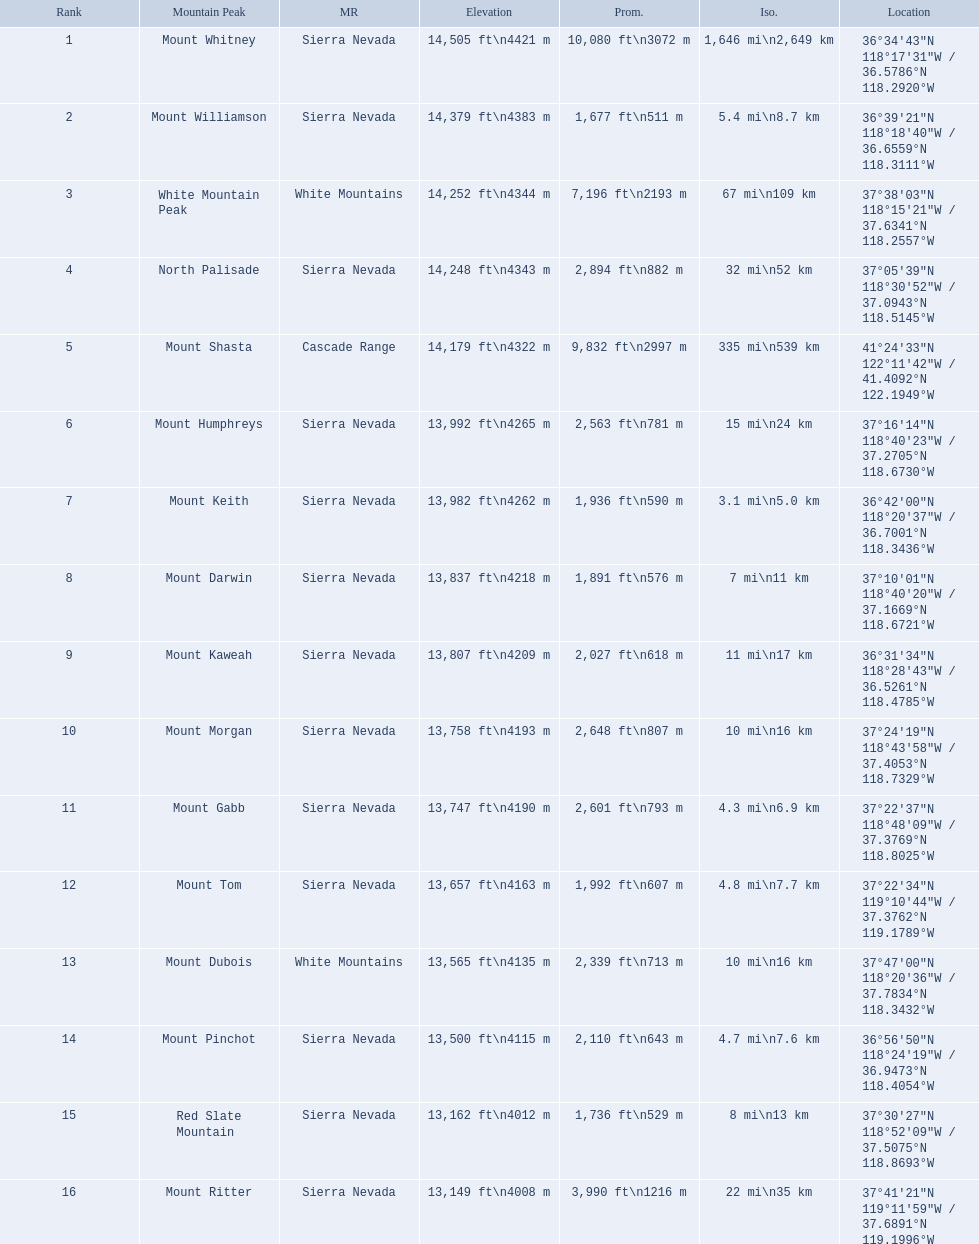Which mountain peaks are lower than 14,000 ft? Mount Humphreys, Mount Keith, Mount Darwin, Mount Kaweah, Mount Morgan, Mount Gabb, Mount Tom, Mount Dubois, Mount Pinchot, Red Slate Mountain, Mount Ritter. Are any of them below 13,500? if so, which ones? Red Slate Mountain, Mount Ritter. What's the lowest peak? 13,149 ft\n4008 m. Write the full table. {'header': ['Rank', 'Mountain Peak', 'MR', 'Elevation', 'Prom.', 'Iso.', 'Location'], 'rows': [['1', 'Mount Whitney', 'Sierra Nevada', '14,505\xa0ft\\n4421\xa0m', '10,080\xa0ft\\n3072\xa0m', '1,646\xa0mi\\n2,649\xa0km', '36°34′43″N 118°17′31″W\ufeff / \ufeff36.5786°N 118.2920°W'], ['2', 'Mount Williamson', 'Sierra Nevada', '14,379\xa0ft\\n4383\xa0m', '1,677\xa0ft\\n511\xa0m', '5.4\xa0mi\\n8.7\xa0km', '36°39′21″N 118°18′40″W\ufeff / \ufeff36.6559°N 118.3111°W'], ['3', 'White Mountain Peak', 'White Mountains', '14,252\xa0ft\\n4344\xa0m', '7,196\xa0ft\\n2193\xa0m', '67\xa0mi\\n109\xa0km', '37°38′03″N 118°15′21″W\ufeff / \ufeff37.6341°N 118.2557°W'], ['4', 'North Palisade', 'Sierra Nevada', '14,248\xa0ft\\n4343\xa0m', '2,894\xa0ft\\n882\xa0m', '32\xa0mi\\n52\xa0km', '37°05′39″N 118°30′52″W\ufeff / \ufeff37.0943°N 118.5145°W'], ['5', 'Mount Shasta', 'Cascade Range', '14,179\xa0ft\\n4322\xa0m', '9,832\xa0ft\\n2997\xa0m', '335\xa0mi\\n539\xa0km', '41°24′33″N 122°11′42″W\ufeff / \ufeff41.4092°N 122.1949°W'], ['6', 'Mount Humphreys', 'Sierra Nevada', '13,992\xa0ft\\n4265\xa0m', '2,563\xa0ft\\n781\xa0m', '15\xa0mi\\n24\xa0km', '37°16′14″N 118°40′23″W\ufeff / \ufeff37.2705°N 118.6730°W'], ['7', 'Mount Keith', 'Sierra Nevada', '13,982\xa0ft\\n4262\xa0m', '1,936\xa0ft\\n590\xa0m', '3.1\xa0mi\\n5.0\xa0km', '36°42′00″N 118°20′37″W\ufeff / \ufeff36.7001°N 118.3436°W'], ['8', 'Mount Darwin', 'Sierra Nevada', '13,837\xa0ft\\n4218\xa0m', '1,891\xa0ft\\n576\xa0m', '7\xa0mi\\n11\xa0km', '37°10′01″N 118°40′20″W\ufeff / \ufeff37.1669°N 118.6721°W'], ['9', 'Mount Kaweah', 'Sierra Nevada', '13,807\xa0ft\\n4209\xa0m', '2,027\xa0ft\\n618\xa0m', '11\xa0mi\\n17\xa0km', '36°31′34″N 118°28′43″W\ufeff / \ufeff36.5261°N 118.4785°W'], ['10', 'Mount Morgan', 'Sierra Nevada', '13,758\xa0ft\\n4193\xa0m', '2,648\xa0ft\\n807\xa0m', '10\xa0mi\\n16\xa0km', '37°24′19″N 118°43′58″W\ufeff / \ufeff37.4053°N 118.7329°W'], ['11', 'Mount Gabb', 'Sierra Nevada', '13,747\xa0ft\\n4190\xa0m', '2,601\xa0ft\\n793\xa0m', '4.3\xa0mi\\n6.9\xa0km', '37°22′37″N 118°48′09″W\ufeff / \ufeff37.3769°N 118.8025°W'], ['12', 'Mount Tom', 'Sierra Nevada', '13,657\xa0ft\\n4163\xa0m', '1,992\xa0ft\\n607\xa0m', '4.8\xa0mi\\n7.7\xa0km', '37°22′34″N 119°10′44″W\ufeff / \ufeff37.3762°N 119.1789°W'], ['13', 'Mount Dubois', 'White Mountains', '13,565\xa0ft\\n4135\xa0m', '2,339\xa0ft\\n713\xa0m', '10\xa0mi\\n16\xa0km', '37°47′00″N 118°20′36″W\ufeff / \ufeff37.7834°N 118.3432°W'], ['14', 'Mount Pinchot', 'Sierra Nevada', '13,500\xa0ft\\n4115\xa0m', '2,110\xa0ft\\n643\xa0m', '4.7\xa0mi\\n7.6\xa0km', '36°56′50″N 118°24′19″W\ufeff / \ufeff36.9473°N 118.4054°W'], ['15', 'Red Slate Mountain', 'Sierra Nevada', '13,162\xa0ft\\n4012\xa0m', '1,736\xa0ft\\n529\xa0m', '8\xa0mi\\n13\xa0km', '37°30′27″N 118°52′09″W\ufeff / \ufeff37.5075°N 118.8693°W'], ['16', 'Mount Ritter', 'Sierra Nevada', '13,149\xa0ft\\n4008\xa0m', '3,990\xa0ft\\n1216\xa0m', '22\xa0mi\\n35\xa0km', '37°41′21″N 119°11′59″W\ufeff / \ufeff37.6891°N 119.1996°W']]} Which one is that? Mount Ritter. What are the heights of the peaks? 14,505 ft\n4421 m, 14,379 ft\n4383 m, 14,252 ft\n4344 m, 14,248 ft\n4343 m, 14,179 ft\n4322 m, 13,992 ft\n4265 m, 13,982 ft\n4262 m, 13,837 ft\n4218 m, 13,807 ft\n4209 m, 13,758 ft\n4193 m, 13,747 ft\n4190 m, 13,657 ft\n4163 m, 13,565 ft\n4135 m, 13,500 ft\n4115 m, 13,162 ft\n4012 m, 13,149 ft\n4008 m. Which of these heights is tallest? 14,505 ft\n4421 m. What peak is 14,505 feet? Mount Whitney. 